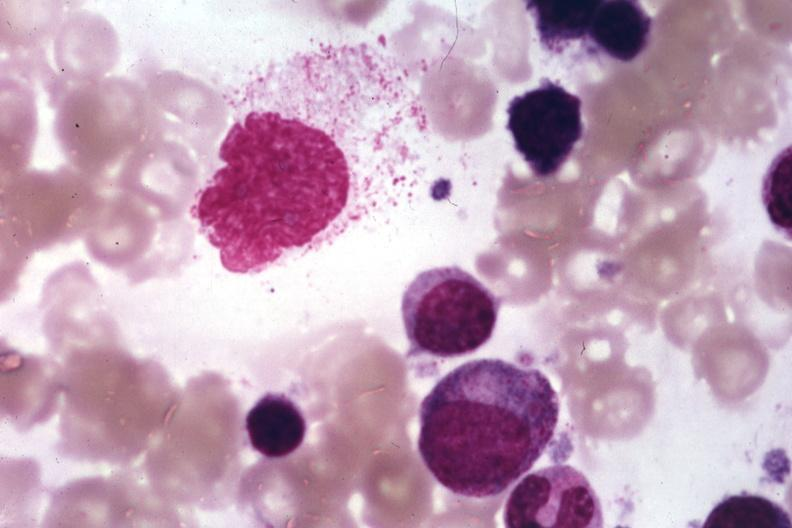does hypertension show wrights?
Answer the question using a single word or phrase. No 